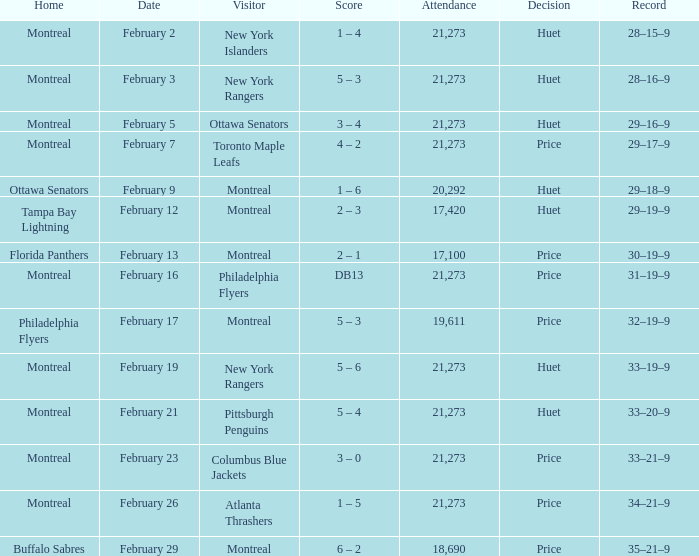Who was the visiting team at the game when the Canadiens had a record of 30–19–9? Montreal. 